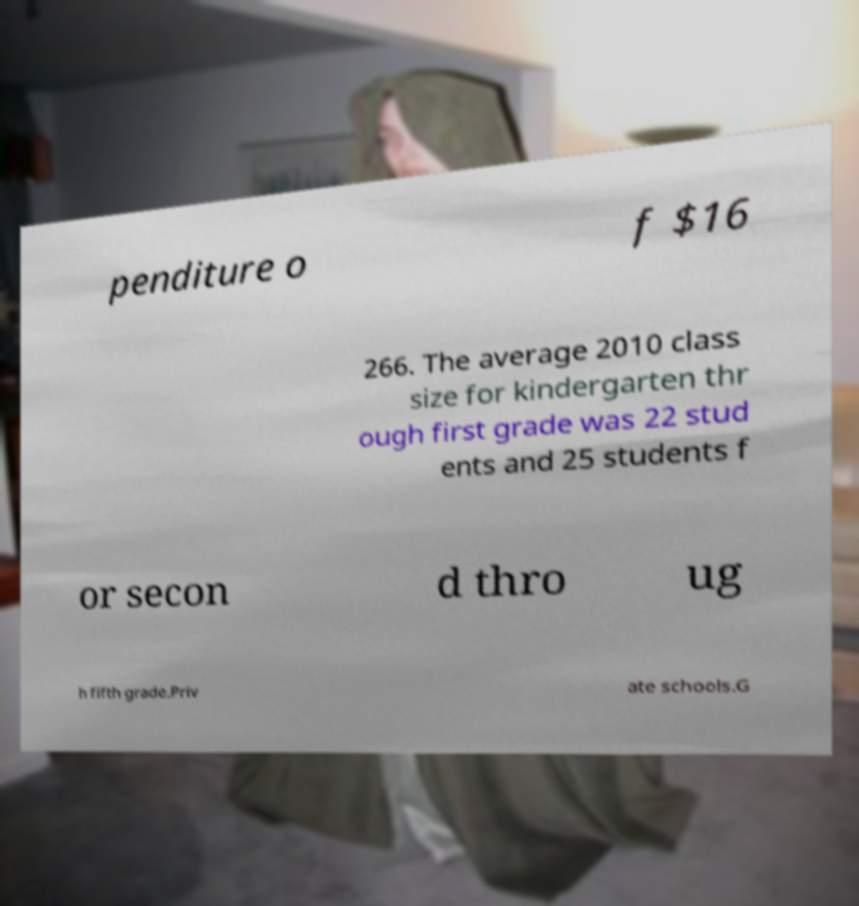Please read and relay the text visible in this image. What does it say? penditure o f $16 266. The average 2010 class size for kindergarten thr ough first grade was 22 stud ents and 25 students f or secon d thro ug h fifth grade.Priv ate schools.G 